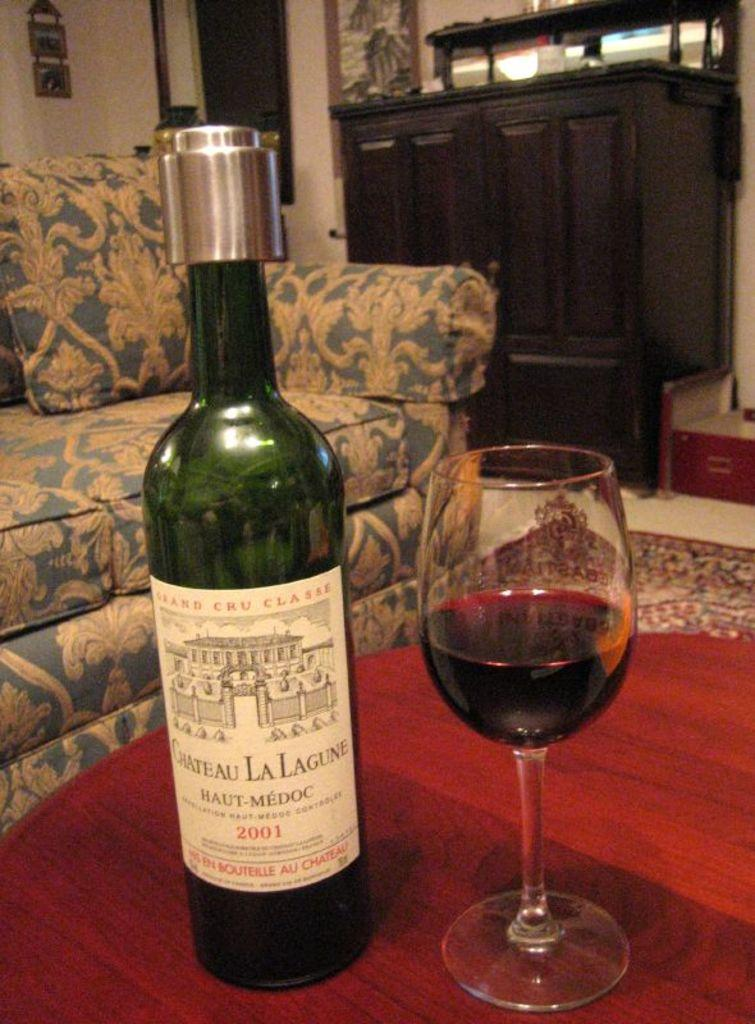<image>
Offer a succinct explanation of the picture presented. a bottle and glass of Chateau La Lagune sits on a table 